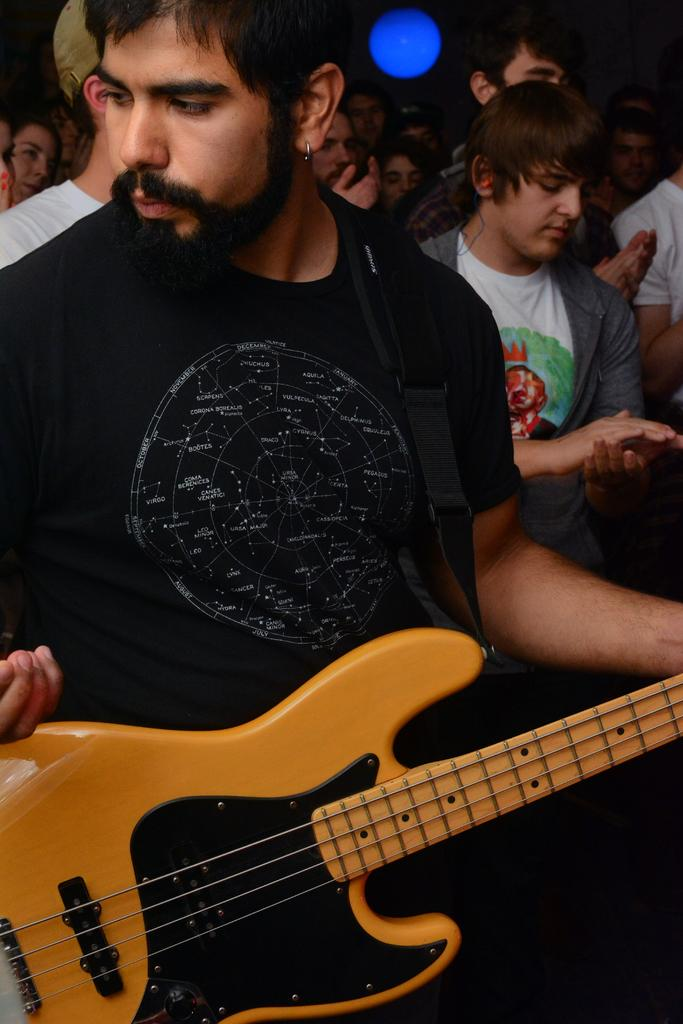What is the man on the bottom left side of the image doing? The man is standing on the bottom left side of the image and holding a guitar. Are there any other people in the image? Yes, there are people standing behind the man. What can be seen at the top of the image? There is a blue color light at the top of the image. How does the man sort the head of the guitar in the image? There is no indication in the image that the man is sorting the head of the guitar, as he is simply holding it. 